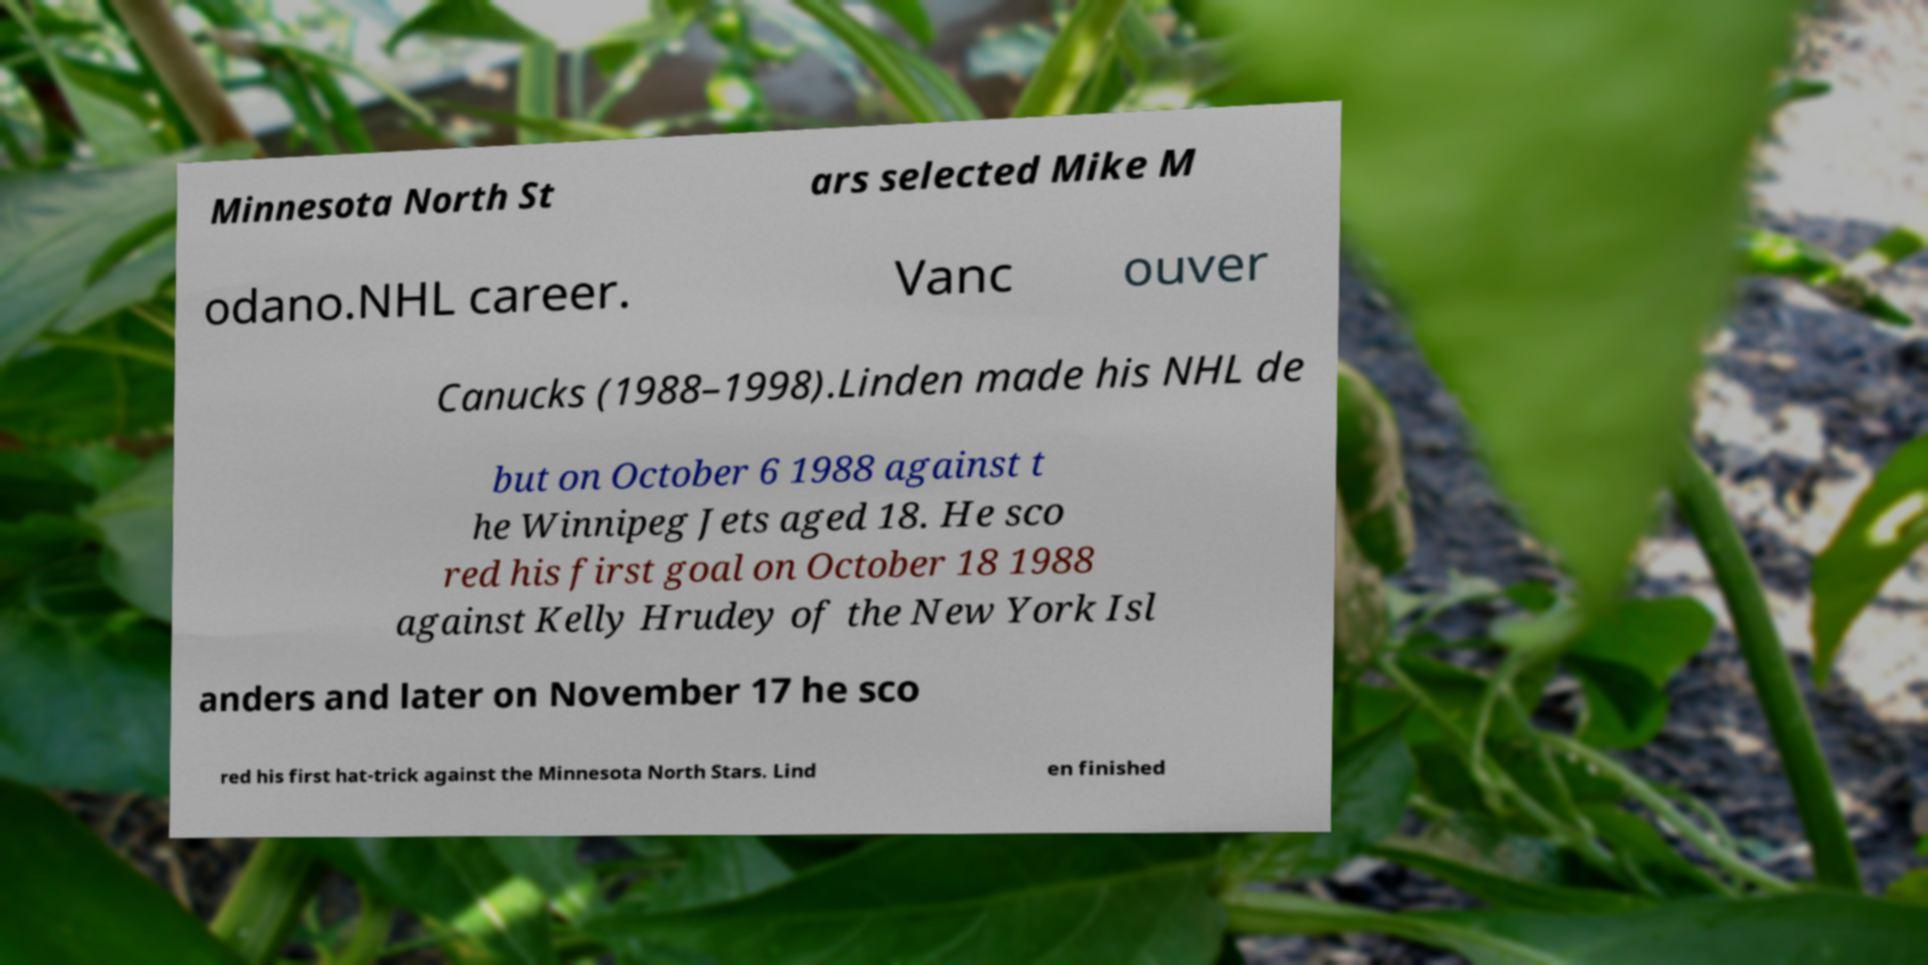Please read and relay the text visible in this image. What does it say? Minnesota North St ars selected Mike M odano.NHL career. Vanc ouver Canucks (1988–1998).Linden made his NHL de but on October 6 1988 against t he Winnipeg Jets aged 18. He sco red his first goal on October 18 1988 against Kelly Hrudey of the New York Isl anders and later on November 17 he sco red his first hat-trick against the Minnesota North Stars. Lind en finished 